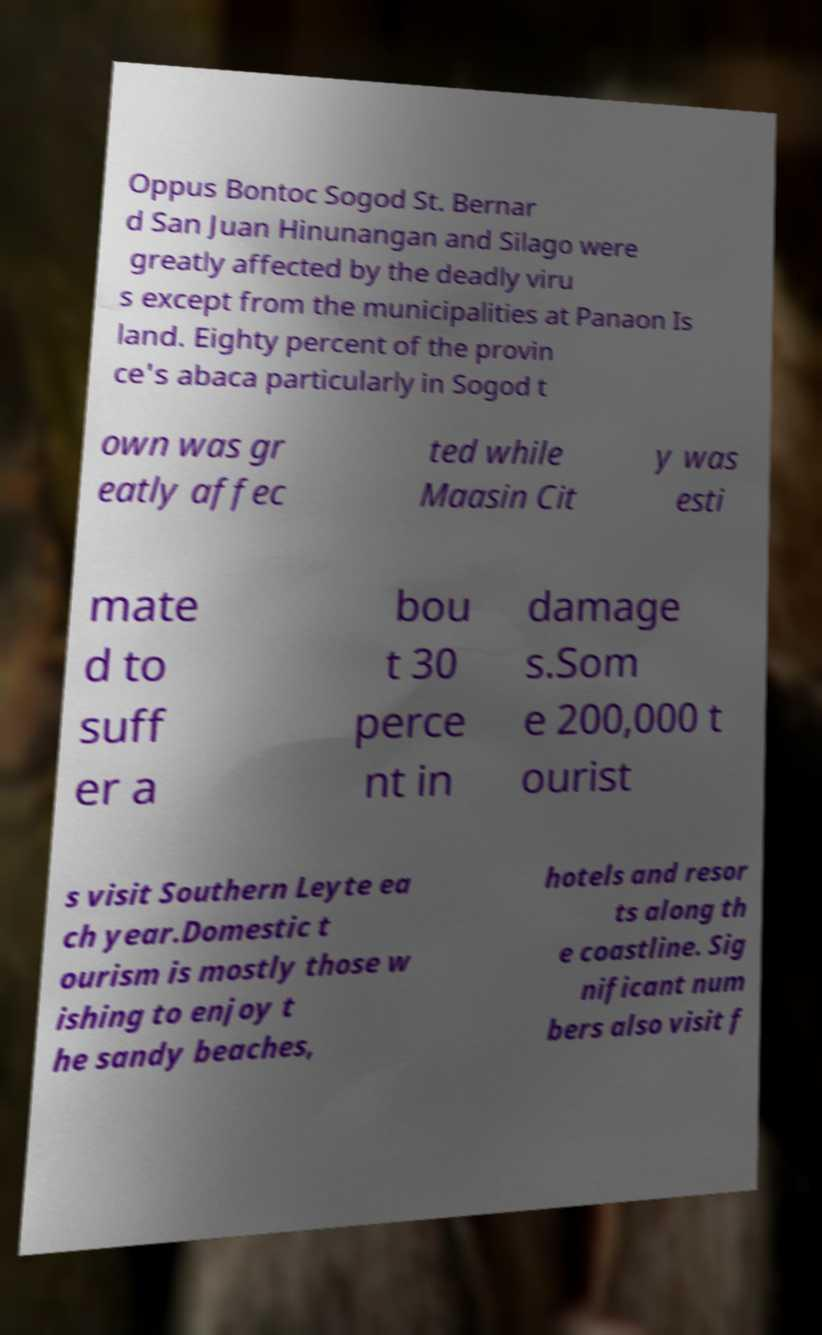Please identify and transcribe the text found in this image. Oppus Bontoc Sogod St. Bernar d San Juan Hinunangan and Silago were greatly affected by the deadly viru s except from the municipalities at Panaon Is land. Eighty percent of the provin ce's abaca particularly in Sogod t own was gr eatly affec ted while Maasin Cit y was esti mate d to suff er a bou t 30 perce nt in damage s.Som e 200,000 t ourist s visit Southern Leyte ea ch year.Domestic t ourism is mostly those w ishing to enjoy t he sandy beaches, hotels and resor ts along th e coastline. Sig nificant num bers also visit f 